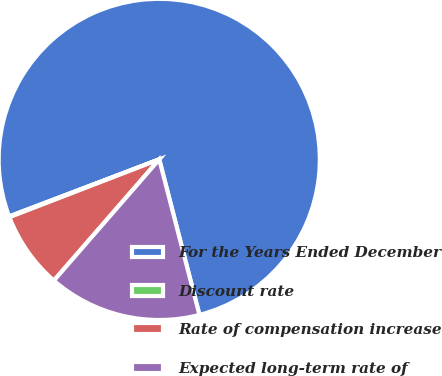Convert chart. <chart><loc_0><loc_0><loc_500><loc_500><pie_chart><fcel>For the Years Ended December<fcel>Discount rate<fcel>Rate of compensation increase<fcel>Expected long-term rate of<nl><fcel>76.75%<fcel>0.08%<fcel>7.75%<fcel>15.42%<nl></chart> 